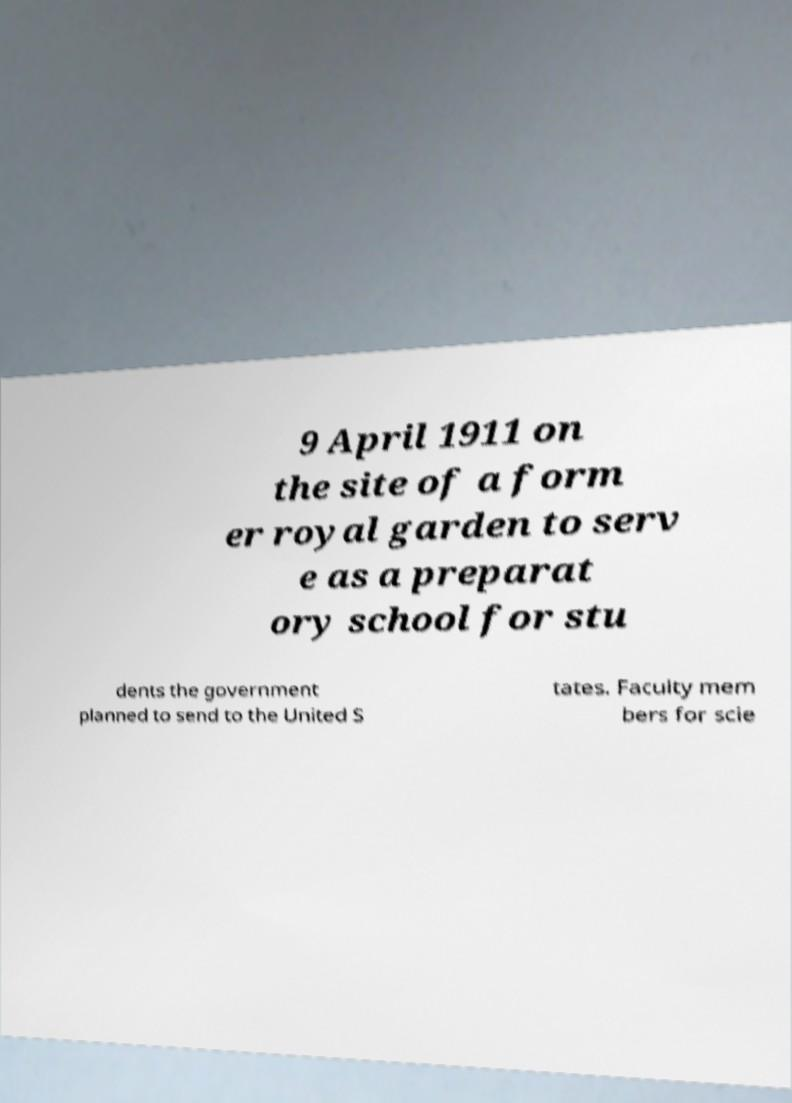There's text embedded in this image that I need extracted. Can you transcribe it verbatim? 9 April 1911 on the site of a form er royal garden to serv e as a preparat ory school for stu dents the government planned to send to the United S tates. Faculty mem bers for scie 